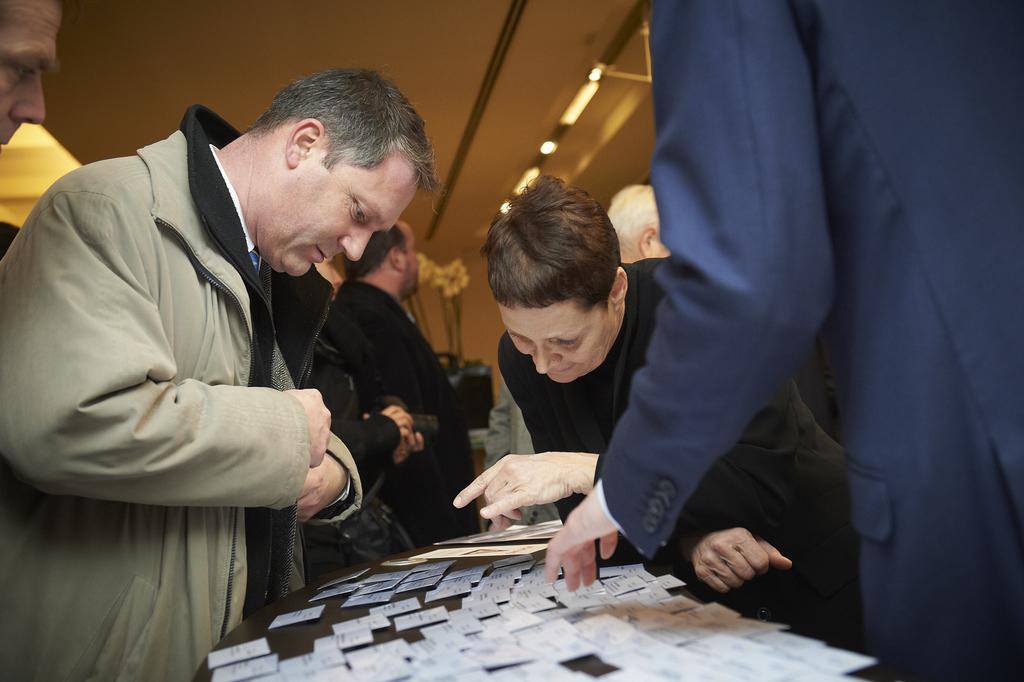What is happening in the image involving people? There are people standing in the image. What objects can be seen on the table in the image? There are papers on a table in the image. What can be seen at the top of the image? There are lights at the top of the image. What type of meat is being cooked on the friction-induced cord in the image? There is no meat or cord present in the image. 